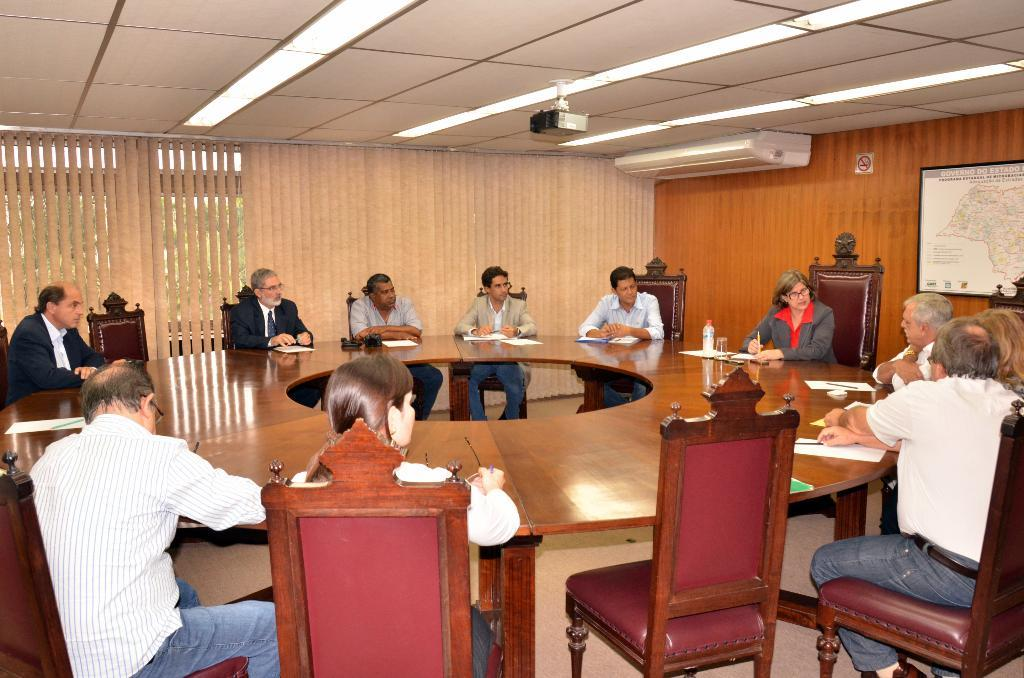What is the main subject of the image? The main subject of the image is a group of people. Where are the people in the image located? The people are sitting around a table in the image. What can be seen at the top of the image? There is a light at the top of the image. Can you describe the position of the man in the image? The man is on the right side of the image. What type of insect is crawling on the table in the image? There is no insect present on the table in the image. In which direction are the people facing in the image? The image does not provide enough information to determine the direction the people are facing. 